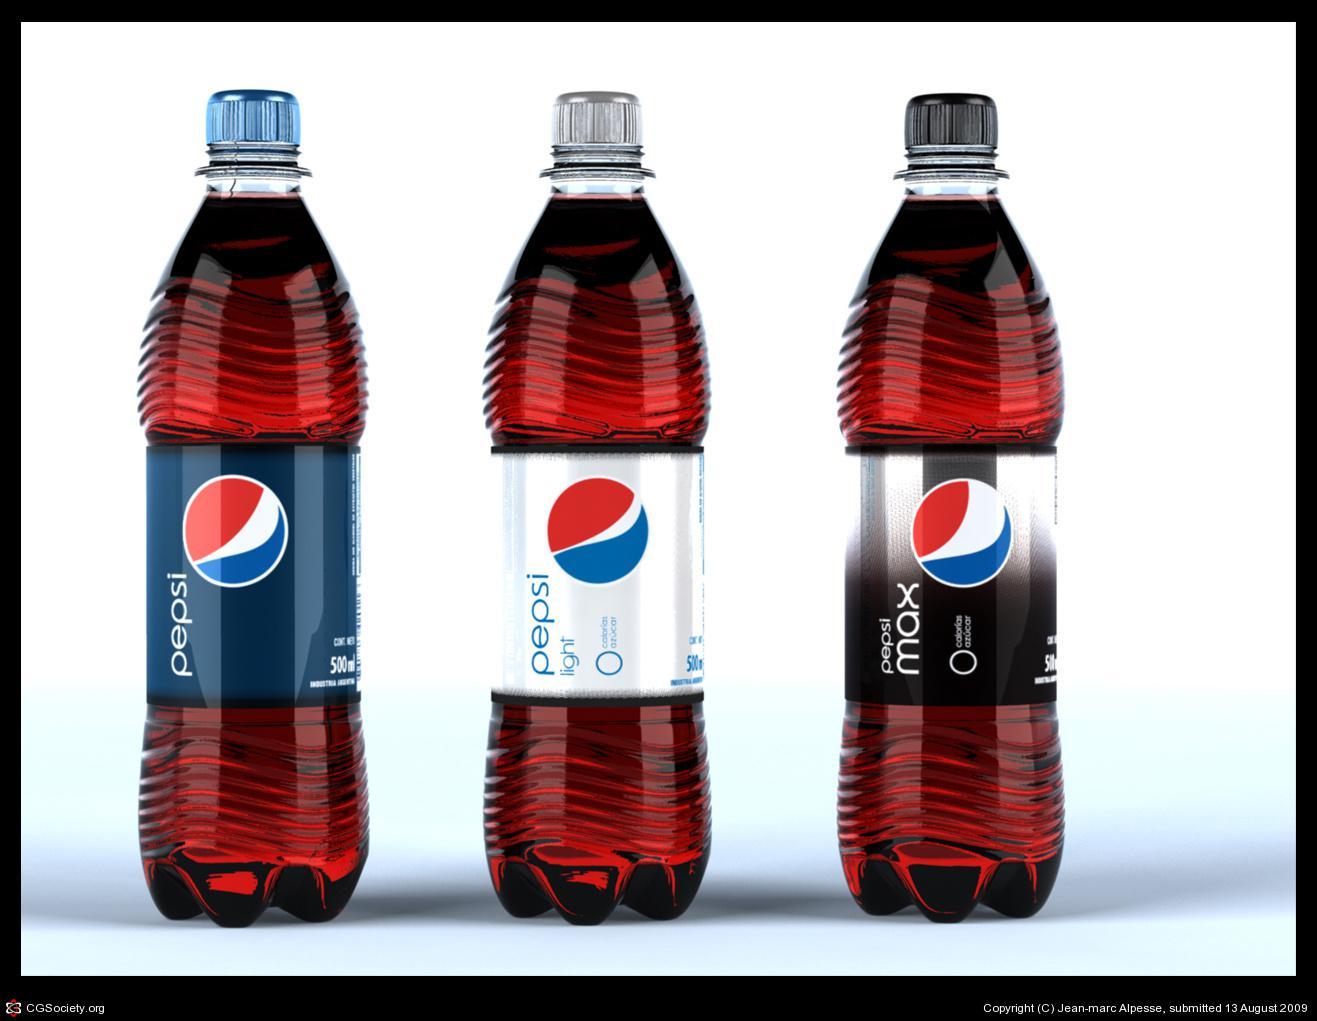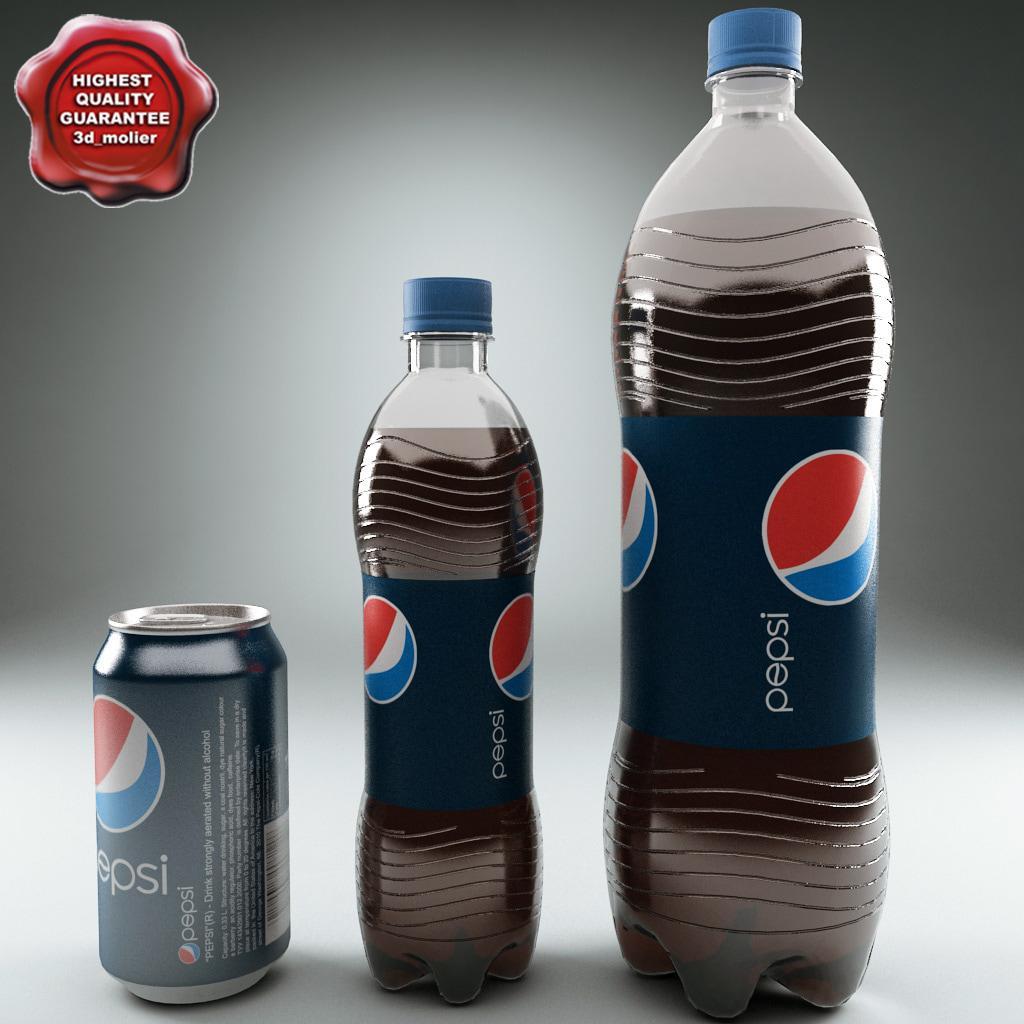The first image is the image on the left, the second image is the image on the right. Analyze the images presented: Is the assertion "One of the images has 3 bottles, while the other one has 4." valid? Answer yes or no. No. The first image is the image on the left, the second image is the image on the right. Assess this claim about the two images: "There are exactly seven bottles.". Correct or not? Answer yes or no. No. 